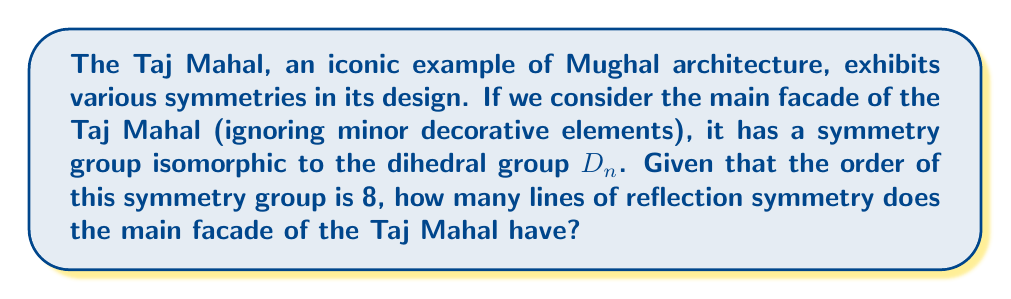Solve this math problem. To solve this problem, let's break it down step-by-step:

1) The symmetry group of the Taj Mahal's main facade is isomorphic to $D_n$, where $n$ is the number of lines of reflection symmetry.

2) The order of the dihedral group $D_n$ is given by the formula:

   $$|D_n| = 2n$$

3) We are given that the order of the symmetry group is 8. So we can set up the equation:

   $$8 = 2n$$

4) Solving for $n$:

   $$n = \frac{8}{2} = 4$$

5) Therefore, the main facade of the Taj Mahal has 4 lines of reflection symmetry.

To visualize this, we can think of the Taj Mahal's facade as having:
- Vertical symmetry (reflection across the central vertical axis)
- Horizontal symmetry (reflection across the central horizontal axis)
- Two diagonal lines of symmetry (from top-left to bottom-right and top-right to bottom-left)

These four lines of symmetry, combined with the rotational symmetries (0°, 90°, 180°, 270°), give us the 8 elements of the $D_4$ group.

[asy]
size(200);
fill((-1,-1)--(1,-1)--(1,1)--(-1,1)--cycle, white);
draw((-1,-1)--(1,-1)--(1,1)--(-1,1)--cycle);
draw((-1,-1)--(1,1), dashed);
draw((1,-1)--(-1,1), dashed);
draw((0,-1)--(0,1));
draw((-1,0)--(1,0));
label("Taj Mahal Facade", (0,-1.2), S);
[/asy]

This symmetry analysis aligns with the actual architecture of the Taj Mahal, which is known for its perfect symmetry and harmonious proportions, reflecting the mathematical precision employed in Mughal architecture.
Answer: The main facade of the Taj Mahal has 4 lines of reflection symmetry. 